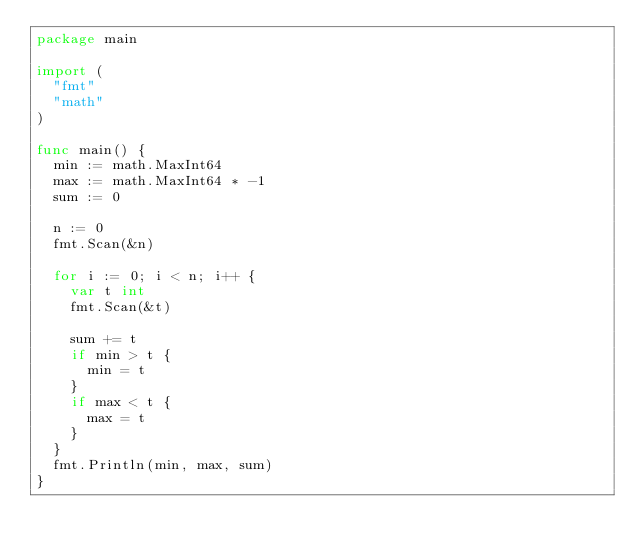Convert code to text. <code><loc_0><loc_0><loc_500><loc_500><_Go_>package main

import (
	"fmt"
	"math"
)

func main() {
	min := math.MaxInt64
	max := math.MaxInt64 * -1
	sum := 0

	n := 0
	fmt.Scan(&n)

	for i := 0; i < n; i++ {
		var t int
		fmt.Scan(&t)

		sum += t
		if min > t {
			min = t
		}
		if max < t {
			max = t
		}
	}
	fmt.Println(min, max, sum)
}

</code> 